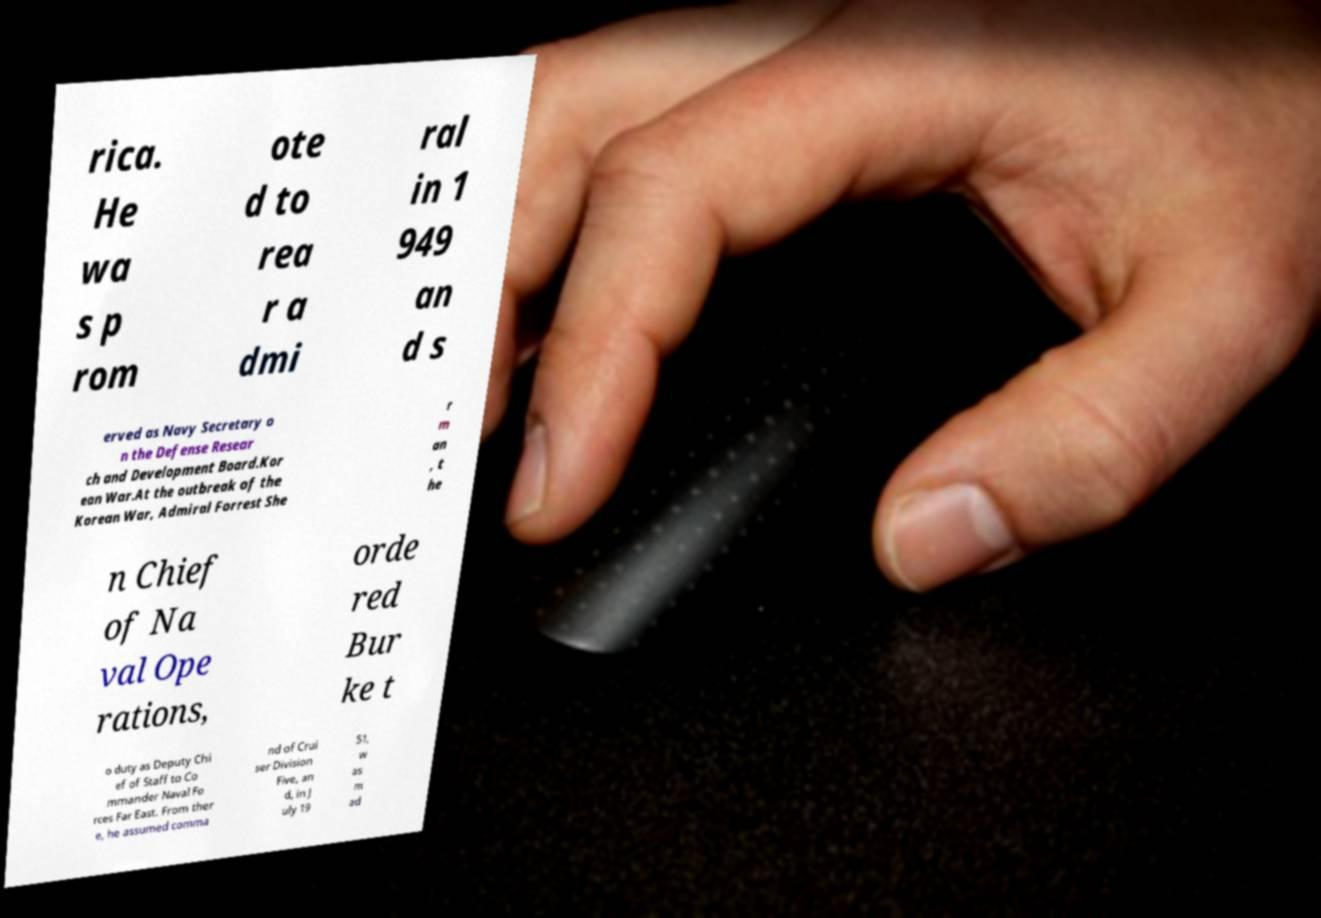Can you read and provide the text displayed in the image?This photo seems to have some interesting text. Can you extract and type it out for me? rica. He wa s p rom ote d to rea r a dmi ral in 1 949 an d s erved as Navy Secretary o n the Defense Resear ch and Development Board.Kor ean War.At the outbreak of the Korean War, Admiral Forrest She r m an , t he n Chief of Na val Ope rations, orde red Bur ke t o duty as Deputy Chi ef of Staff to Co mmander Naval Fo rces Far East. From ther e, he assumed comma nd of Crui ser Division Five, an d, in J uly 19 51, w as m ad 